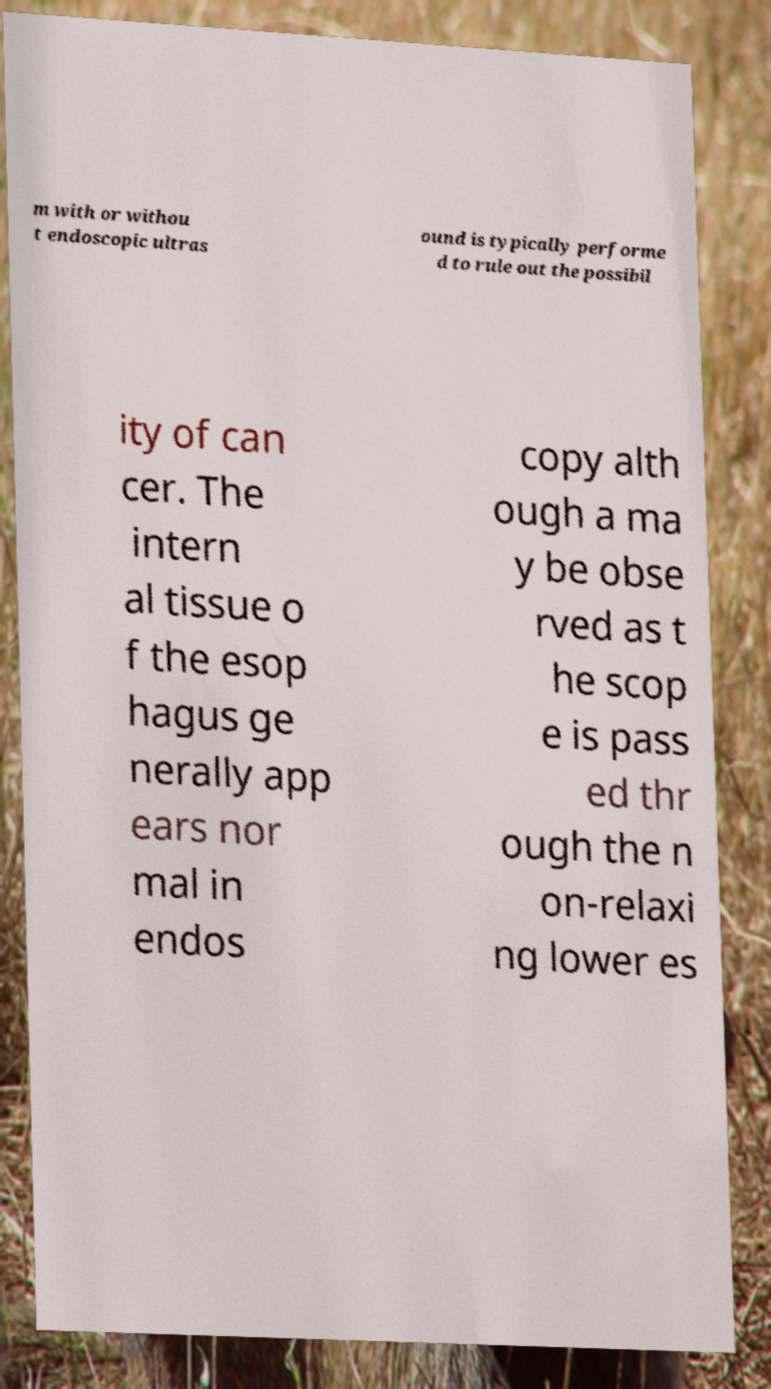I need the written content from this picture converted into text. Can you do that? m with or withou t endoscopic ultras ound is typically performe d to rule out the possibil ity of can cer. The intern al tissue o f the esop hagus ge nerally app ears nor mal in endos copy alth ough a ma y be obse rved as t he scop e is pass ed thr ough the n on-relaxi ng lower es 